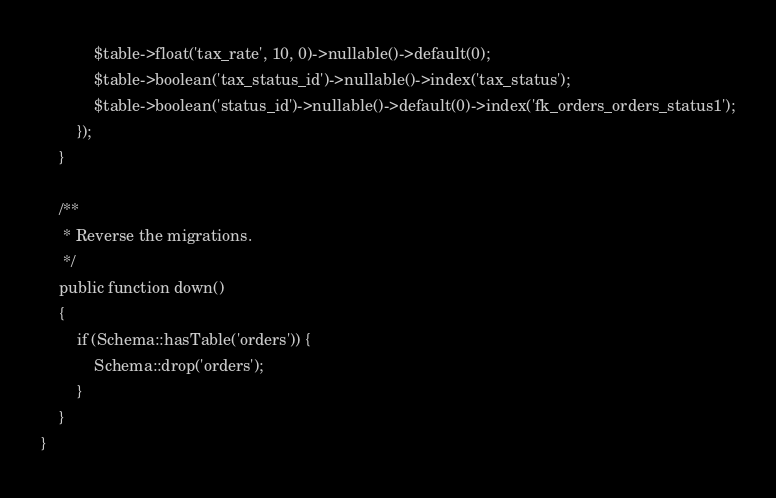Convert code to text. <code><loc_0><loc_0><loc_500><loc_500><_PHP_>            $table->float('tax_rate', 10, 0)->nullable()->default(0);
            $table->boolean('tax_status_id')->nullable()->index('tax_status');
            $table->boolean('status_id')->nullable()->default(0)->index('fk_orders_orders_status1');
        });
    }

    /**
     * Reverse the migrations.
     */
    public function down()
    {
        if (Schema::hasTable('orders')) {
            Schema::drop('orders');
        }
    }
}
</code> 